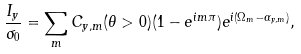Convert formula to latex. <formula><loc_0><loc_0><loc_500><loc_500>\frac { I _ { y } } { \sigma _ { 0 } } = \sum _ { m } C _ { y , m } ( \theta > 0 ) ( 1 - e ^ { i m \pi } ) e ^ { i ( \Omega _ { m } - \alpha _ { y , m } ) } ,</formula> 